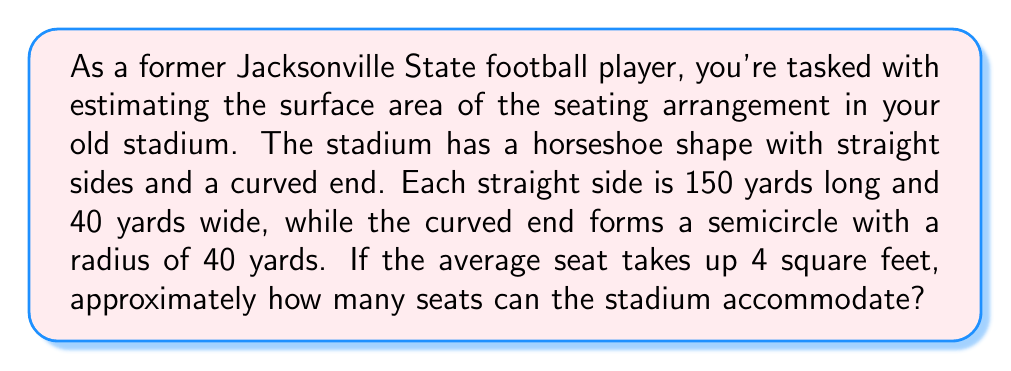Provide a solution to this math problem. Let's approach this step-by-step:

1) First, we need to calculate the total surface area of the seating arrangement.

2) The stadium consists of two rectangular sections (the straight sides) and a semicircular section.

3) Area of one rectangular section:
   $A_r = 150 \text{ yards} \times 40 \text{ yards} = 6000 \text{ square yards}$

4) Total area of both rectangular sections:
   $A_{total_r} = 2 \times 6000 = 12000 \text{ square yards}$

5) Area of the semicircular section:
   $A_s = \frac{1}{2} \pi r^2 = \frac{1}{2} \pi (40)^2 = 800\pi \text{ square yards}$

6) Total surface area:
   $A_{total} = 12000 + 800\pi \text{ square yards}$

7) Convert to square feet:
   $A_{total} = (12000 + 800\pi) \times 9 \text{ sq ft} \approx 131,513 \text{ sq ft}$

8) Number of seats:
   $\text{Number of seats} = \frac{131,513 \text{ sq ft}}{4 \text{ sq ft per seat}} \approx 32,878$

9) Rounding to the nearest thousand for an estimate:
   $\text{Estimated number of seats} \approx 33,000$

[asy]
unitsize(1cm);
draw((0,0)--(15,0)--(15,4)--(0,4)--cycle);
draw((15,0)--(15,4),dashed);
draw(arc((15,2),2,270,90));
label("150 yards", (7.5,-0.5));
label("40 yards", (15.5,2));
label("r=40 yards", (17,2));
[/asy]
Answer: Approximately 33,000 seats 